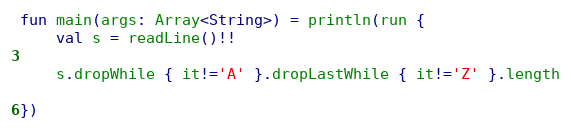<code> <loc_0><loc_0><loc_500><loc_500><_Kotlin_>fun main(args: Array<String>) = println(run {
    val s = readLine()!!

    s.dropWhile { it!='A' }.dropLastWhile { it!='Z' }.length
    
})
</code> 